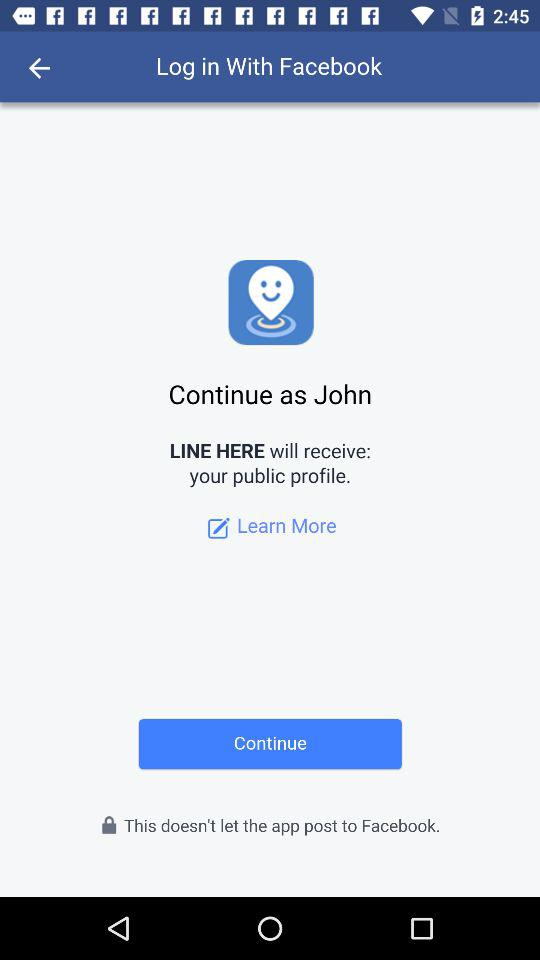What is the login name? The login name is John. 